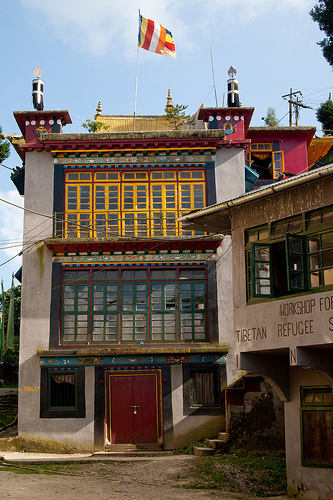<image>
Is the flag behind the door? No. The flag is not behind the door. From this viewpoint, the flag appears to be positioned elsewhere in the scene. 